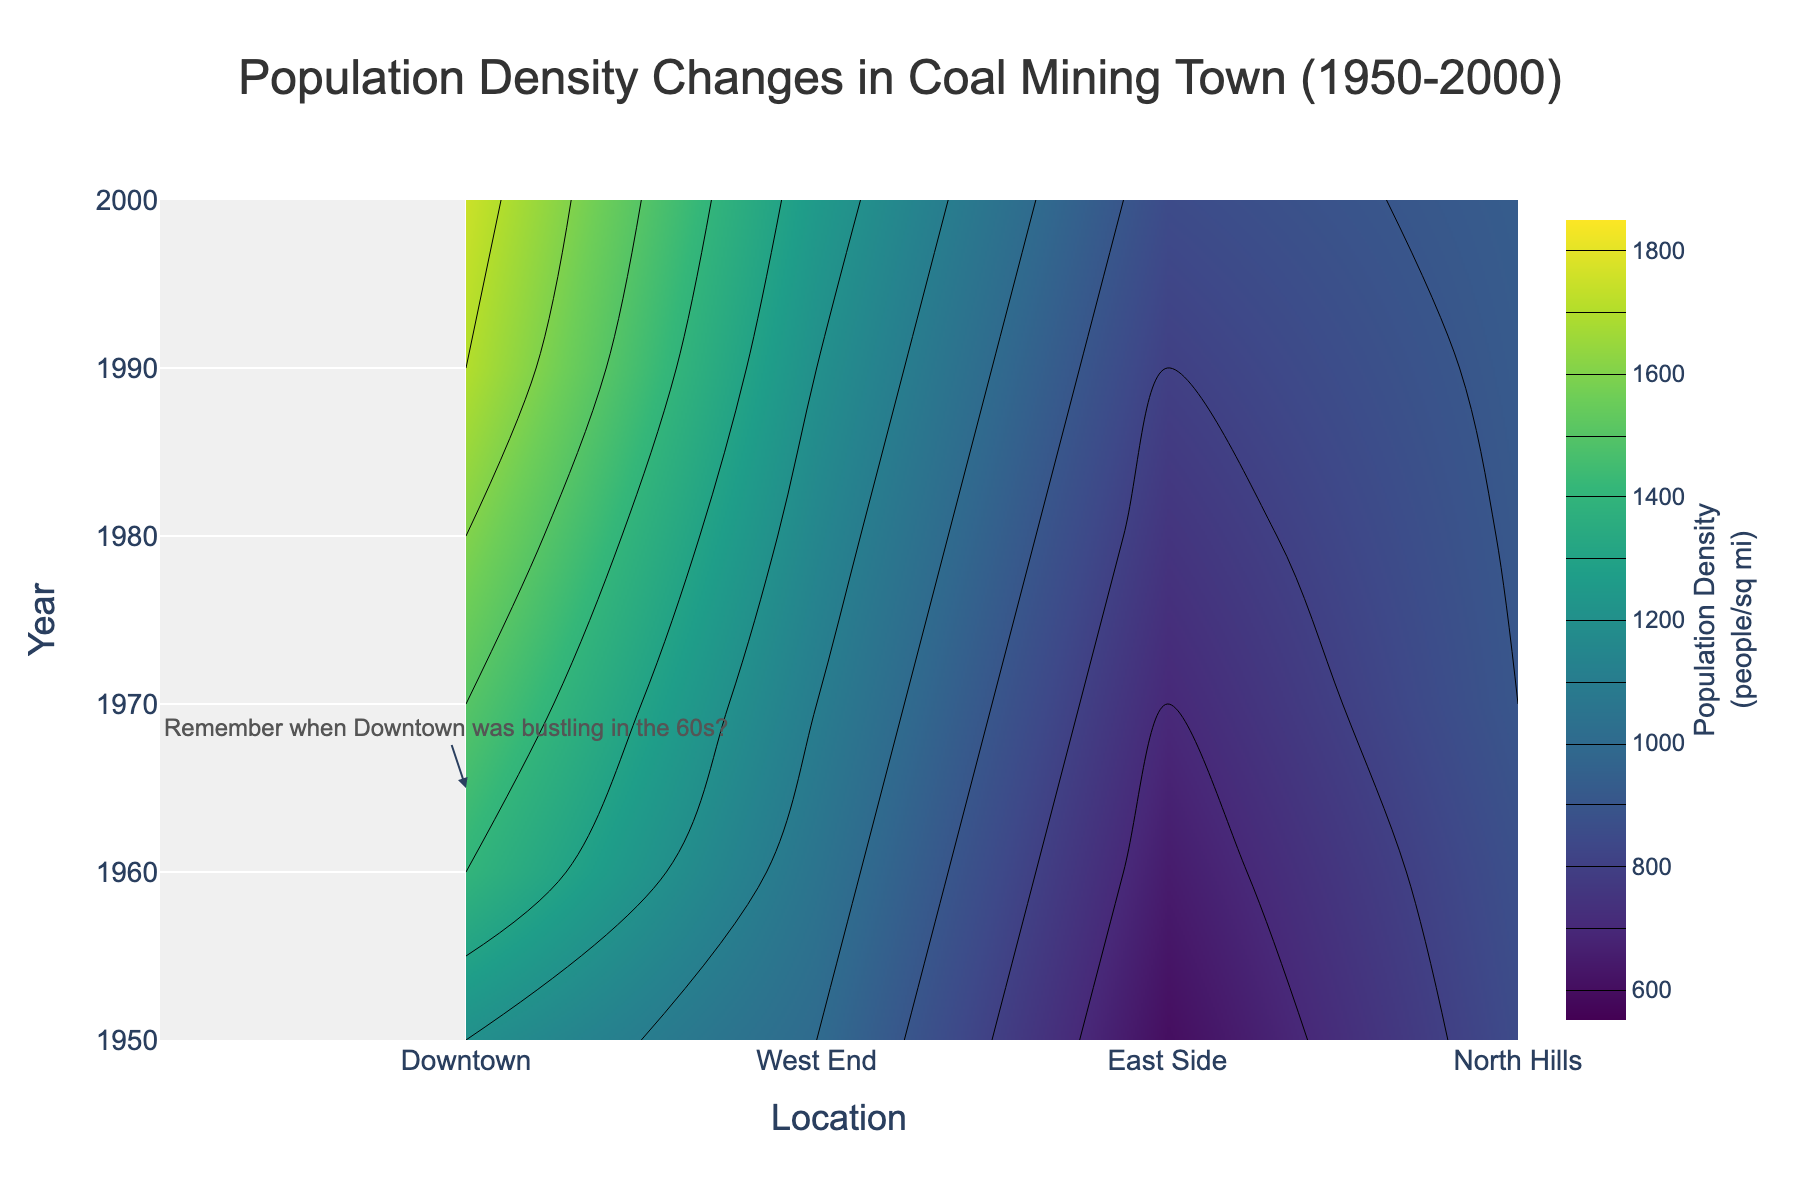What's the title of the figure? The title of the figure is found at the top and describes the overall content. Look for the largest text which usually stands out clearly.
Answer: Population Density Changes in Coal Mining Town (1950-2000) Over which years does the data range? The y-axis represents the years. By looking at the starting and ending points of the y-axis, you can determine the range of years.
Answer: 1950-2000 Which location had the highest population density in 1990? Find the contour region for the year 1990 on the y-axis, and then identify the location along the x-axis with the highest value within that contour.
Answer: Downtown How did the population density of the East Side change from 1950 to 2000? Look for the value on the contour plot corresponding to the East Side from 1950 to 2000 and observe the trend.
Answer: It increased from 1000 to 1250 people/sq mi What's the average population density in Downtown during the decades shown? Extract the population densities of Downtown for each decade, sum them up, and divide by the total number of decades.
Answer: 1533.33 people/sq mi Compare the population density between West End and North Hills in 1980. Which was higher? Locate the population densities of West End and North Hills for the year 1980 and compare the values directly.
Answer: West End Which decades experienced the biggest increase in population density for Downtown? Inspect Downtown's contours and find the decades with the largest difference in values between consecutive decade intervals.
Answer: 1950-1960 What is the total population density sum for North Hills over the five decades? Add up the population density values for North Hills from 1950-2000 (600 + 650 + 700 + 750 + 800).
Answer: 3500 people/sq mi Did any location show a decline in population density over any given decade? Examine the contours for each location across the decades to check for any downward trend in population density values.
Answer: No Which location had the most stable population density change over the decades? Compare the magnitude of changes across decades for all locations, and identify the one with the smallest fluctuation.
Answer: West End 